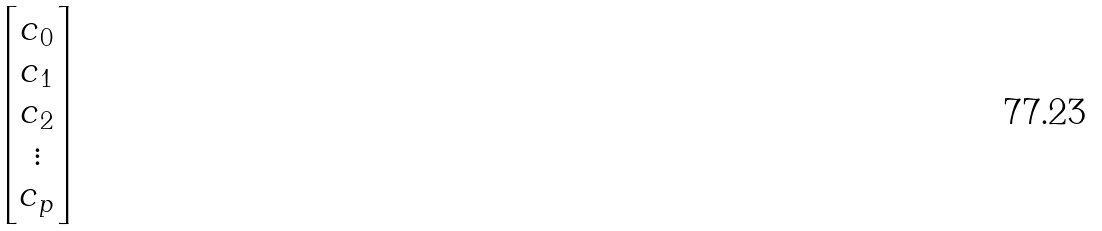Convert formula to latex. <formula><loc_0><loc_0><loc_500><loc_500>\begin{bmatrix} c _ { 0 } \\ c _ { 1 } \\ c _ { 2 } \\ \vdots \\ c _ { p } \end{bmatrix}</formula> 